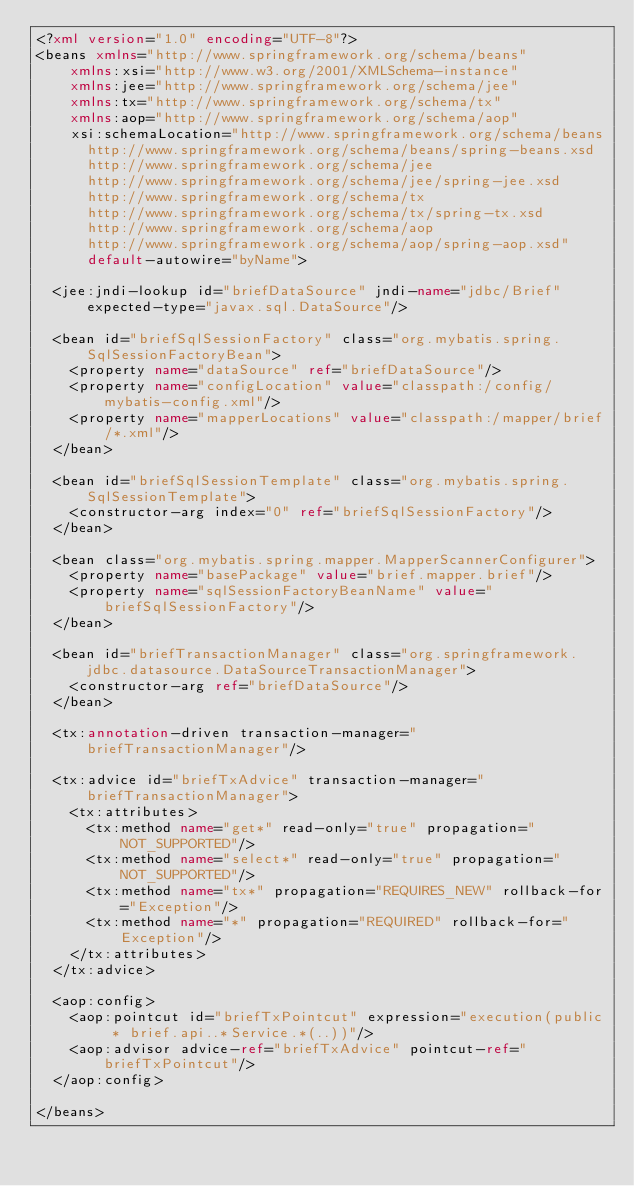Convert code to text. <code><loc_0><loc_0><loc_500><loc_500><_XML_><?xml version="1.0" encoding="UTF-8"?>
<beans xmlns="http://www.springframework.org/schema/beans"
    xmlns:xsi="http://www.w3.org/2001/XMLSchema-instance"
    xmlns:jee="http://www.springframework.org/schema/jee"
    xmlns:tx="http://www.springframework.org/schema/tx"
    xmlns:aop="http://www.springframework.org/schema/aop"
    xsi:schemaLocation="http://www.springframework.org/schema/beans
      http://www.springframework.org/schema/beans/spring-beans.xsd
      http://www.springframework.org/schema/jee
      http://www.springframework.org/schema/jee/spring-jee.xsd
      http://www.springframework.org/schema/tx
      http://www.springframework.org/schema/tx/spring-tx.xsd
      http://www.springframework.org/schema/aop
      http://www.springframework.org/schema/aop/spring-aop.xsd"
      default-autowire="byName">

  <jee:jndi-lookup id="briefDataSource" jndi-name="jdbc/Brief" expected-type="javax.sql.DataSource"/>

  <bean id="briefSqlSessionFactory" class="org.mybatis.spring.SqlSessionFactoryBean">
    <property name="dataSource" ref="briefDataSource"/>
    <property name="configLocation" value="classpath:/config/mybatis-config.xml"/>
    <property name="mapperLocations" value="classpath:/mapper/brief/*.xml"/>
  </bean>

  <bean id="briefSqlSessionTemplate" class="org.mybatis.spring.SqlSessionTemplate">
    <constructor-arg index="0" ref="briefSqlSessionFactory"/>
  </bean>

  <bean class="org.mybatis.spring.mapper.MapperScannerConfigurer">
    <property name="basePackage" value="brief.mapper.brief"/>
    <property name="sqlSessionFactoryBeanName" value="briefSqlSessionFactory"/>
  </bean>

  <bean id="briefTransactionManager" class="org.springframework.jdbc.datasource.DataSourceTransactionManager">
    <constructor-arg ref="briefDataSource"/>
  </bean>

  <tx:annotation-driven transaction-manager="briefTransactionManager"/>

  <tx:advice id="briefTxAdvice" transaction-manager="briefTransactionManager">
    <tx:attributes>
      <tx:method name="get*" read-only="true" propagation="NOT_SUPPORTED"/>
      <tx:method name="select*" read-only="true" propagation="NOT_SUPPORTED"/>
      <tx:method name="tx*" propagation="REQUIRES_NEW" rollback-for="Exception"/>
      <tx:method name="*" propagation="REQUIRED" rollback-for="Exception"/>
    </tx:attributes>
  </tx:advice>

  <aop:config>
    <aop:pointcut id="briefTxPointcut" expression="execution(public * brief.api..*Service.*(..))"/>
    <aop:advisor advice-ref="briefTxAdvice" pointcut-ref="briefTxPointcut"/>
  </aop:config>

</beans>
</code> 